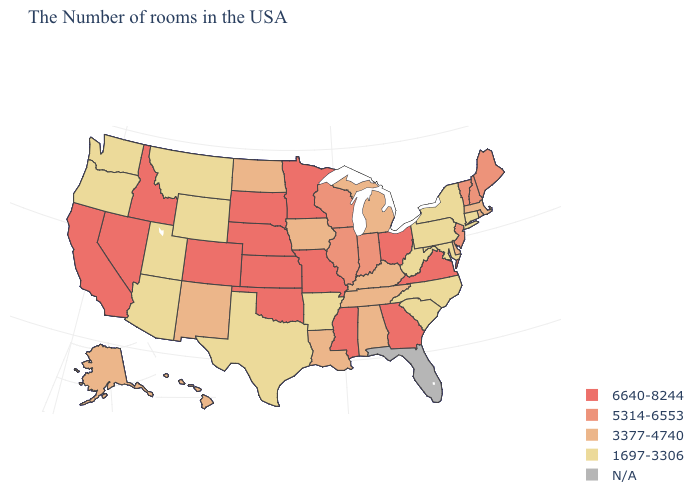What is the highest value in states that border Georgia?
Write a very short answer. 3377-4740. What is the value of New Jersey?
Concise answer only. 5314-6553. Name the states that have a value in the range N/A?
Keep it brief. Florida. What is the value of New York?
Write a very short answer. 1697-3306. Name the states that have a value in the range 5314-6553?
Concise answer only. Maine, New Hampshire, Vermont, New Jersey, Indiana, Wisconsin, Illinois. What is the value of Oregon?
Answer briefly. 1697-3306. Is the legend a continuous bar?
Quick response, please. No. Among the states that border Tennessee , which have the lowest value?
Write a very short answer. North Carolina, Arkansas. Which states hav the highest value in the MidWest?
Write a very short answer. Ohio, Missouri, Minnesota, Kansas, Nebraska, South Dakota. Among the states that border Massachusetts , does New Hampshire have the lowest value?
Concise answer only. No. Does the map have missing data?
Short answer required. Yes. Does the first symbol in the legend represent the smallest category?
Give a very brief answer. No. What is the value of Indiana?
Be succinct. 5314-6553. 